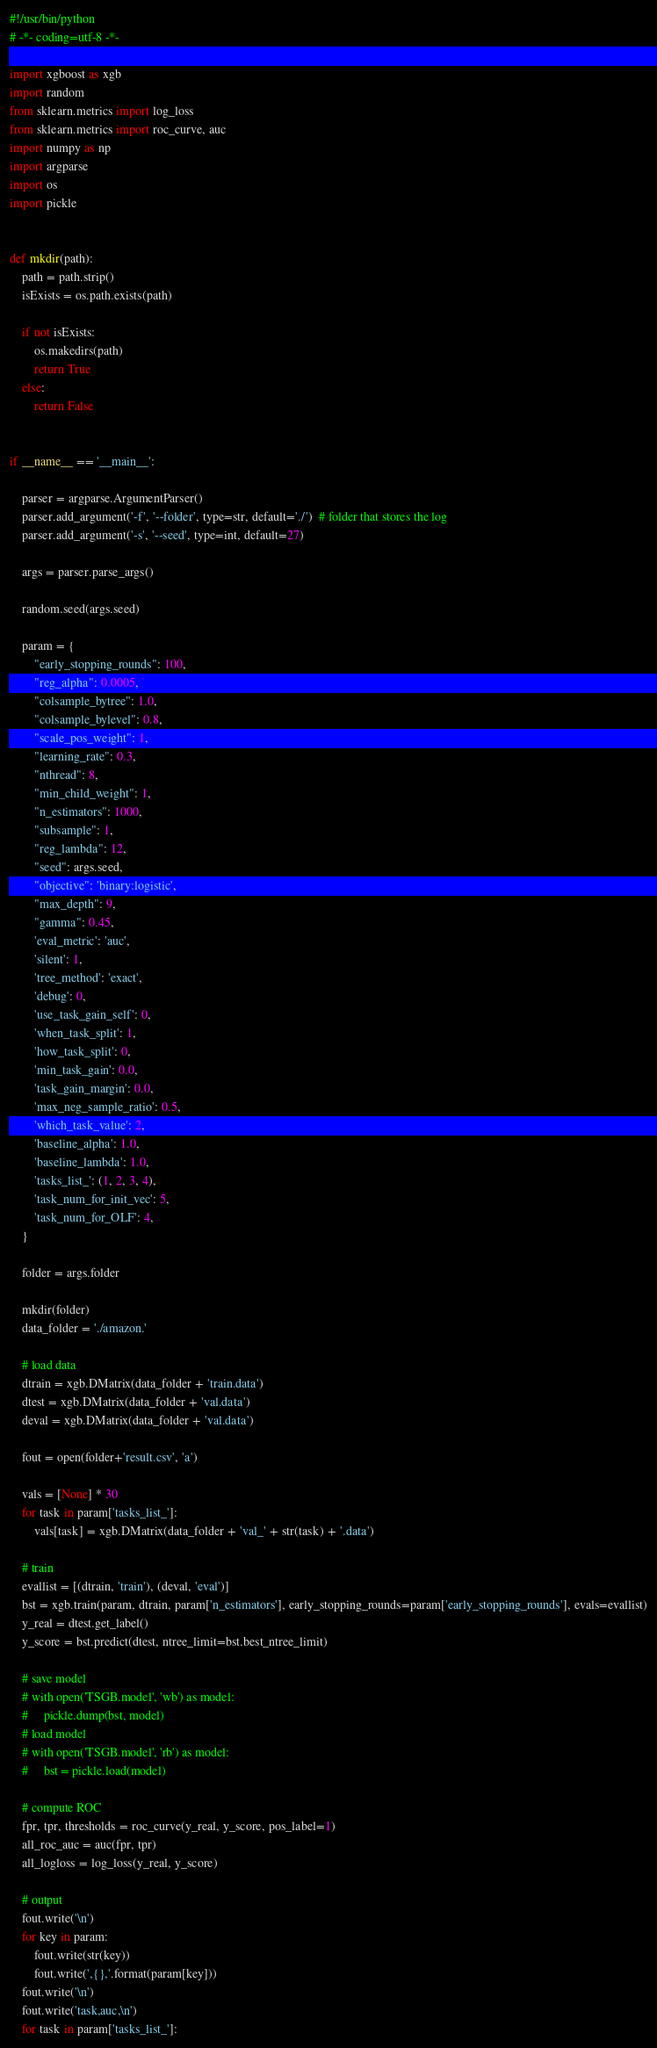Convert code to text. <code><loc_0><loc_0><loc_500><loc_500><_Python_>#!/usr/bin/python
# -*- coding=utf-8 -*-

import xgboost as xgb
import random
from sklearn.metrics import log_loss
from sklearn.metrics import roc_curve, auc
import numpy as np
import argparse
import os
import pickle


def mkdir(path):
    path = path.strip()
    isExists = os.path.exists(path)

    if not isExists:
        os.makedirs(path)
        return True
    else:
        return False


if __name__ == '__main__':

    parser = argparse.ArgumentParser()
    parser.add_argument('-f', '--folder', type=str, default='./')  # folder that stores the log
    parser.add_argument('-s', '--seed', type=int, default=27)

    args = parser.parse_args()

    random.seed(args.seed)

    param = {
        "early_stopping_rounds": 100,
        "reg_alpha": 0.0005,
        "colsample_bytree": 1.0,
        "colsample_bylevel": 0.8,
        "scale_pos_weight": 1,
        "learning_rate": 0.3,
        "nthread": 8,
        "min_child_weight": 1,
        "n_estimators": 1000,
        "subsample": 1,
        "reg_lambda": 12,
        "seed": args.seed,
        "objective": 'binary:logistic',
        "max_depth": 9,
        "gamma": 0.45,
        'eval_metric': 'auc',
        'silent': 1,
        'tree_method': 'exact',
        'debug': 0,
        'use_task_gain_self': 0,
        'when_task_split': 1,
        'how_task_split': 0,
        'min_task_gain': 0.0,
        'task_gain_margin': 0.0,
        'max_neg_sample_ratio': 0.5,
        'which_task_value': 2,
        'baseline_alpha': 1.0,
        'baseline_lambda': 1.0,
        'tasks_list_': (1, 2, 3, 4),
        'task_num_for_init_vec': 5,
        'task_num_for_OLF': 4,
    }

    folder = args.folder

    mkdir(folder)
    data_folder = './amazon.'

    # load data
    dtrain = xgb.DMatrix(data_folder + 'train.data')
    dtest = xgb.DMatrix(data_folder + 'val.data')
    deval = xgb.DMatrix(data_folder + 'val.data')

    fout = open(folder+'result.csv', 'a')

    vals = [None] * 30
    for task in param['tasks_list_']:
        vals[task] = xgb.DMatrix(data_folder + 'val_' + str(task) + '.data')

    # train
    evallist = [(dtrain, 'train'), (deval, 'eval')]
    bst = xgb.train(param, dtrain, param['n_estimators'], early_stopping_rounds=param['early_stopping_rounds'], evals=evallist)
    y_real = dtest.get_label()
    y_score = bst.predict(dtest, ntree_limit=bst.best_ntree_limit)

    # save model
    # with open('TSGB.model', 'wb') as model:
    #     pickle.dump(bst, model)
    # load model
    # with open('TSGB.model', 'rb') as model:
    #     bst = pickle.load(model)

    # compute ROC
    fpr, tpr, thresholds = roc_curve(y_real, y_score, pos_label=1)
    all_roc_auc = auc(fpr, tpr)
    all_logloss = log_loss(y_real, y_score)

    # output
    fout.write('\n')
    for key in param:
        fout.write(str(key))
        fout.write(',{},'.format(param[key]))
    fout.write('\n')
    fout.write('task,auc,\n')
    for task in param['tasks_list_']:</code> 